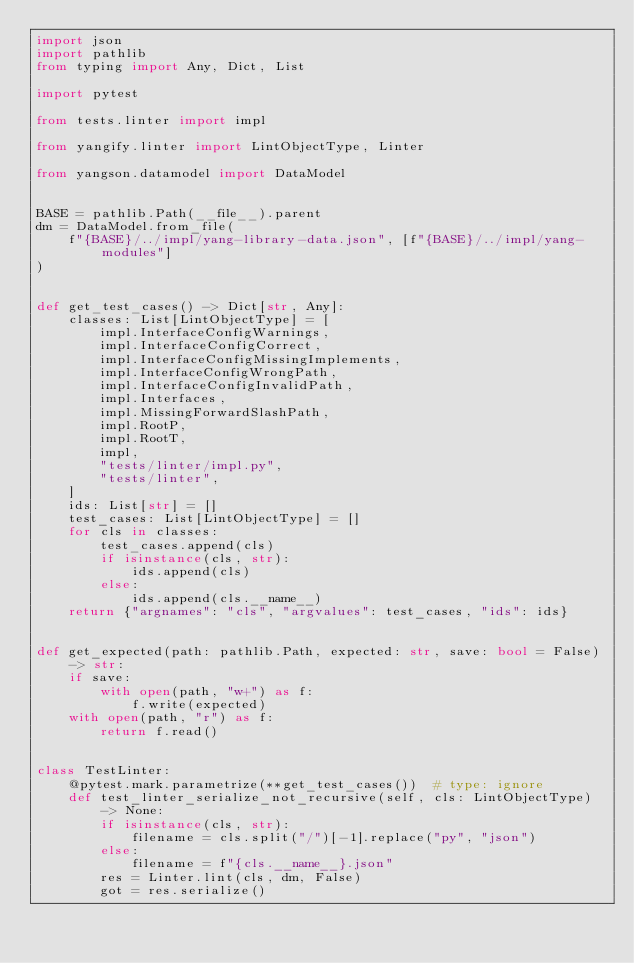Convert code to text. <code><loc_0><loc_0><loc_500><loc_500><_Python_>import json
import pathlib
from typing import Any, Dict, List

import pytest

from tests.linter import impl

from yangify.linter import LintObjectType, Linter

from yangson.datamodel import DataModel


BASE = pathlib.Path(__file__).parent
dm = DataModel.from_file(
    f"{BASE}/../impl/yang-library-data.json", [f"{BASE}/../impl/yang-modules"]
)


def get_test_cases() -> Dict[str, Any]:
    classes: List[LintObjectType] = [
        impl.InterfaceConfigWarnings,
        impl.InterfaceConfigCorrect,
        impl.InterfaceConfigMissingImplements,
        impl.InterfaceConfigWrongPath,
        impl.InterfaceConfigInvalidPath,
        impl.Interfaces,
        impl.MissingForwardSlashPath,
        impl.RootP,
        impl.RootT,
        impl,
        "tests/linter/impl.py",
        "tests/linter",
    ]
    ids: List[str] = []
    test_cases: List[LintObjectType] = []
    for cls in classes:
        test_cases.append(cls)
        if isinstance(cls, str):
            ids.append(cls)
        else:
            ids.append(cls.__name__)
    return {"argnames": "cls", "argvalues": test_cases, "ids": ids}


def get_expected(path: pathlib.Path, expected: str, save: bool = False) -> str:
    if save:
        with open(path, "w+") as f:
            f.write(expected)
    with open(path, "r") as f:
        return f.read()


class TestLinter:
    @pytest.mark.parametrize(**get_test_cases())  # type: ignore
    def test_linter_serialize_not_recursive(self, cls: LintObjectType) -> None:
        if isinstance(cls, str):
            filename = cls.split("/")[-1].replace("py", "json")
        else:
            filename = f"{cls.__name__}.json"
        res = Linter.lint(cls, dm, False)
        got = res.serialize()</code> 